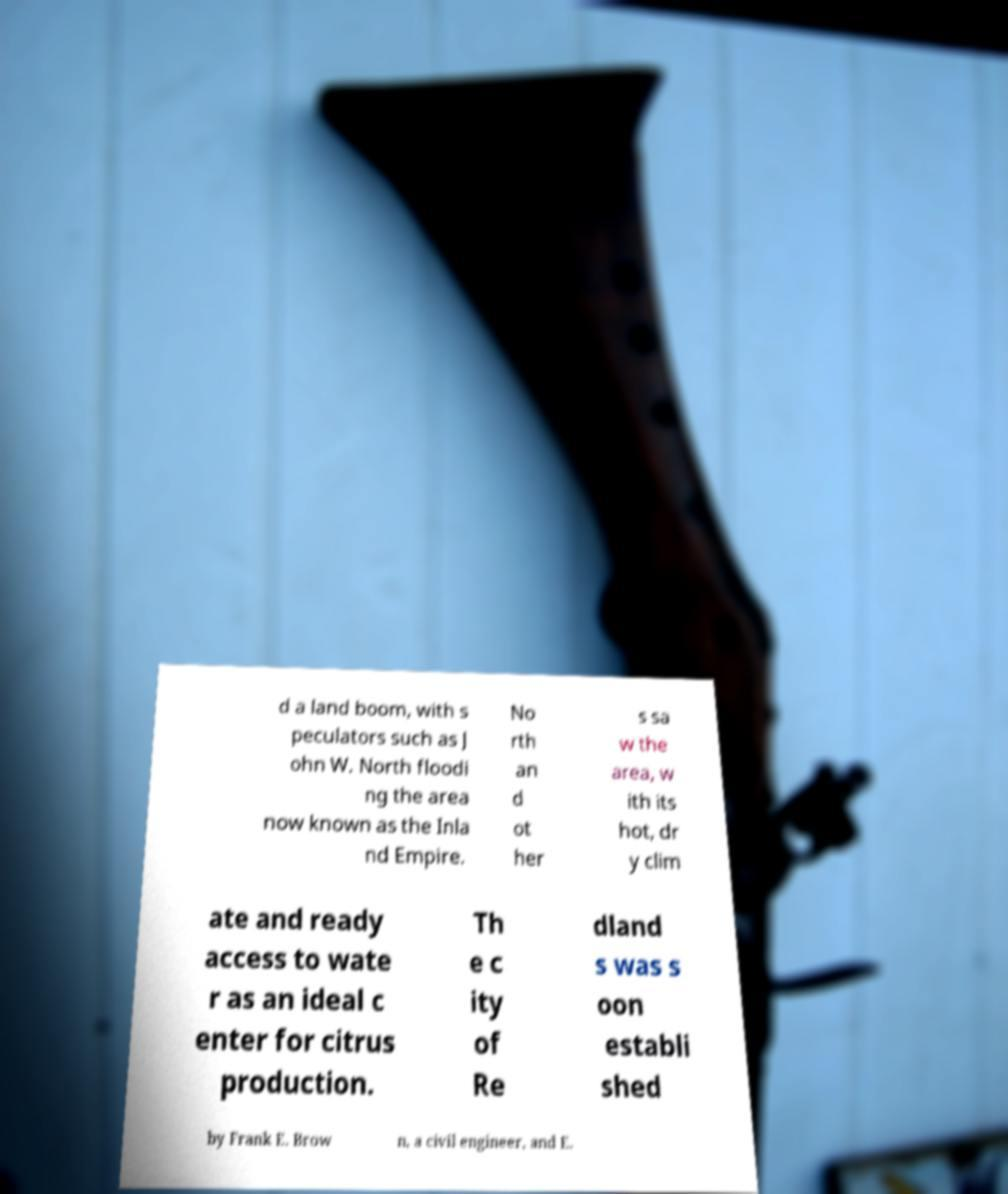Can you read and provide the text displayed in the image?This photo seems to have some interesting text. Can you extract and type it out for me? d a land boom, with s peculators such as J ohn W. North floodi ng the area now known as the Inla nd Empire. No rth an d ot her s sa w the area, w ith its hot, dr y clim ate and ready access to wate r as an ideal c enter for citrus production. Th e c ity of Re dland s was s oon establi shed by Frank E. Brow n, a civil engineer, and E. 